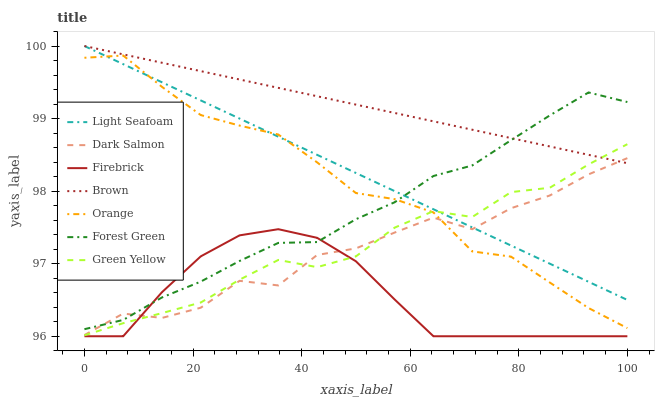Does Firebrick have the minimum area under the curve?
Answer yes or no. Yes. Does Brown have the maximum area under the curve?
Answer yes or no. Yes. Does Green Yellow have the minimum area under the curve?
Answer yes or no. No. Does Green Yellow have the maximum area under the curve?
Answer yes or no. No. Is Light Seafoam the smoothest?
Answer yes or no. Yes. Is Dark Salmon the roughest?
Answer yes or no. Yes. Is Green Yellow the smoothest?
Answer yes or no. No. Is Green Yellow the roughest?
Answer yes or no. No. Does Green Yellow have the lowest value?
Answer yes or no. No. Does Light Seafoam have the highest value?
Answer yes or no. Yes. Does Green Yellow have the highest value?
Answer yes or no. No. Is Firebrick less than Orange?
Answer yes or no. Yes. Is Orange greater than Firebrick?
Answer yes or no. Yes. Does Firebrick intersect Orange?
Answer yes or no. No. 